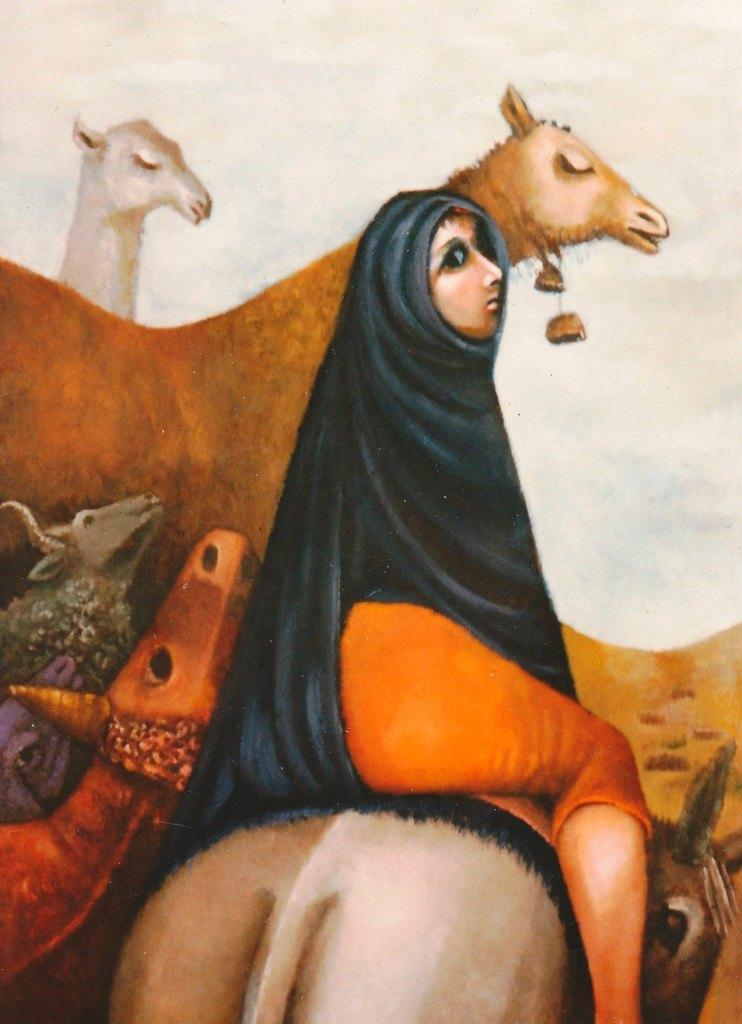What is the main subject of the image? The main subject of the image is a picture. What types of subjects are depicted in the picture? The picture contains animals and a woman. How many beds are visible in the image? There are no beds present in the image; it features a picture with animals and a woman. 